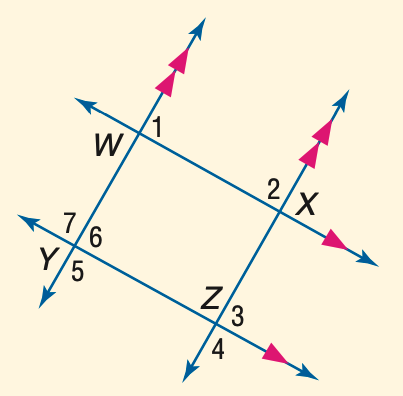Answer the mathemtical geometry problem and directly provide the correct option letter.
Question: In the figure, m \angle 1 = 3 a + 40, m \angle 2 = 2 a + 25, and m \angle 3 = 5 b - 26. Find a.
Choices: A: 23 B: 25 C: 27 D: 29 A 